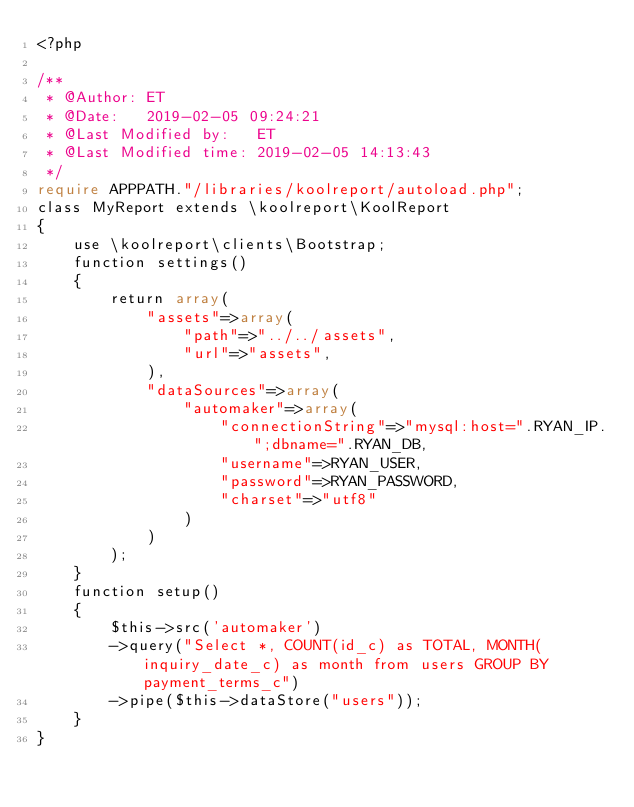<code> <loc_0><loc_0><loc_500><loc_500><_PHP_><?php

/**
 * @Author: ET
 * @Date:   2019-02-05 09:24:21
 * @Last Modified by:   ET
 * @Last Modified time: 2019-02-05 14:13:43
 */
require APPPATH."/libraries/koolreport/autoload.php";
class MyReport extends \koolreport\KoolReport
{
    use \koolreport\clients\Bootstrap;
    function settings()
    {
        return array(
            "assets"=>array(
                "path"=>"../../assets",
                "url"=>"assets",
            ),
            "dataSources"=>array(
                "automaker"=>array(
                    "connectionString"=>"mysql:host=".RYAN_IP.";dbname=".RYAN_DB,
                    "username"=>RYAN_USER,
                    "password"=>RYAN_PASSWORD,
                    "charset"=>"utf8"
                )
            )
        );
    }
    function setup()
    {
        $this->src('automaker')
        ->query("Select *, COUNT(id_c) as TOTAL, MONTH(inquiry_date_c) as month from users GROUP BY payment_terms_c")
        ->pipe($this->dataStore("users"));
    }
}</code> 